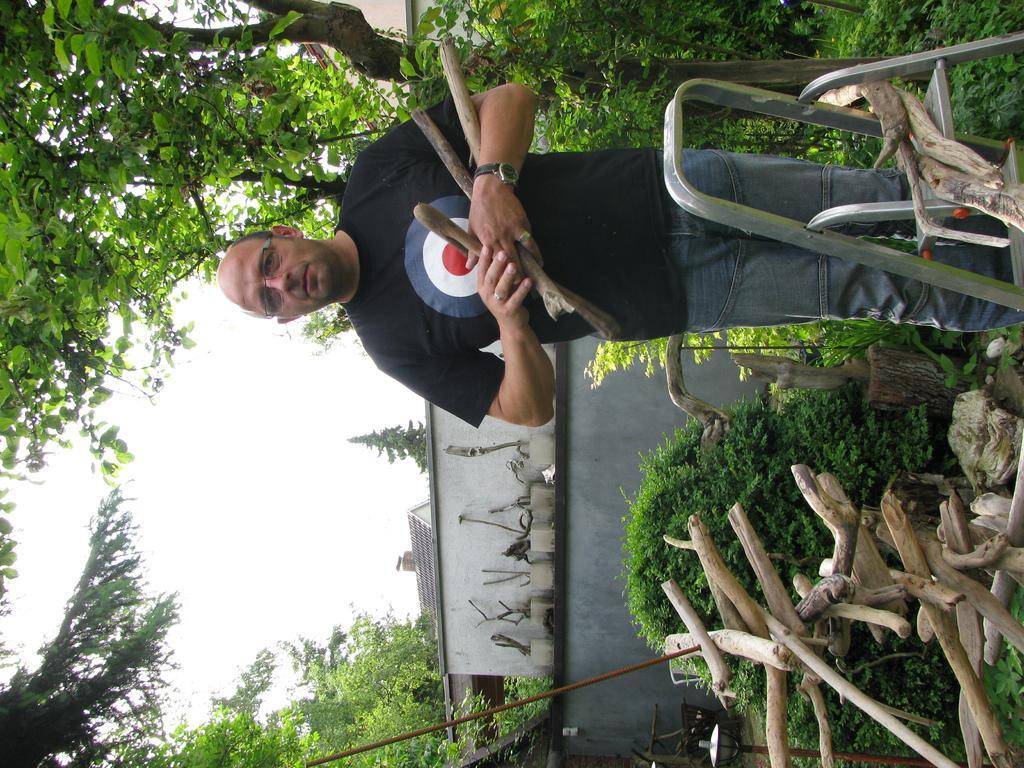Could you give a brief overview of what you see in this image? In this picture there is a man in the image, by holding wooden sticks in his hands and there are trees around the area of the image. 